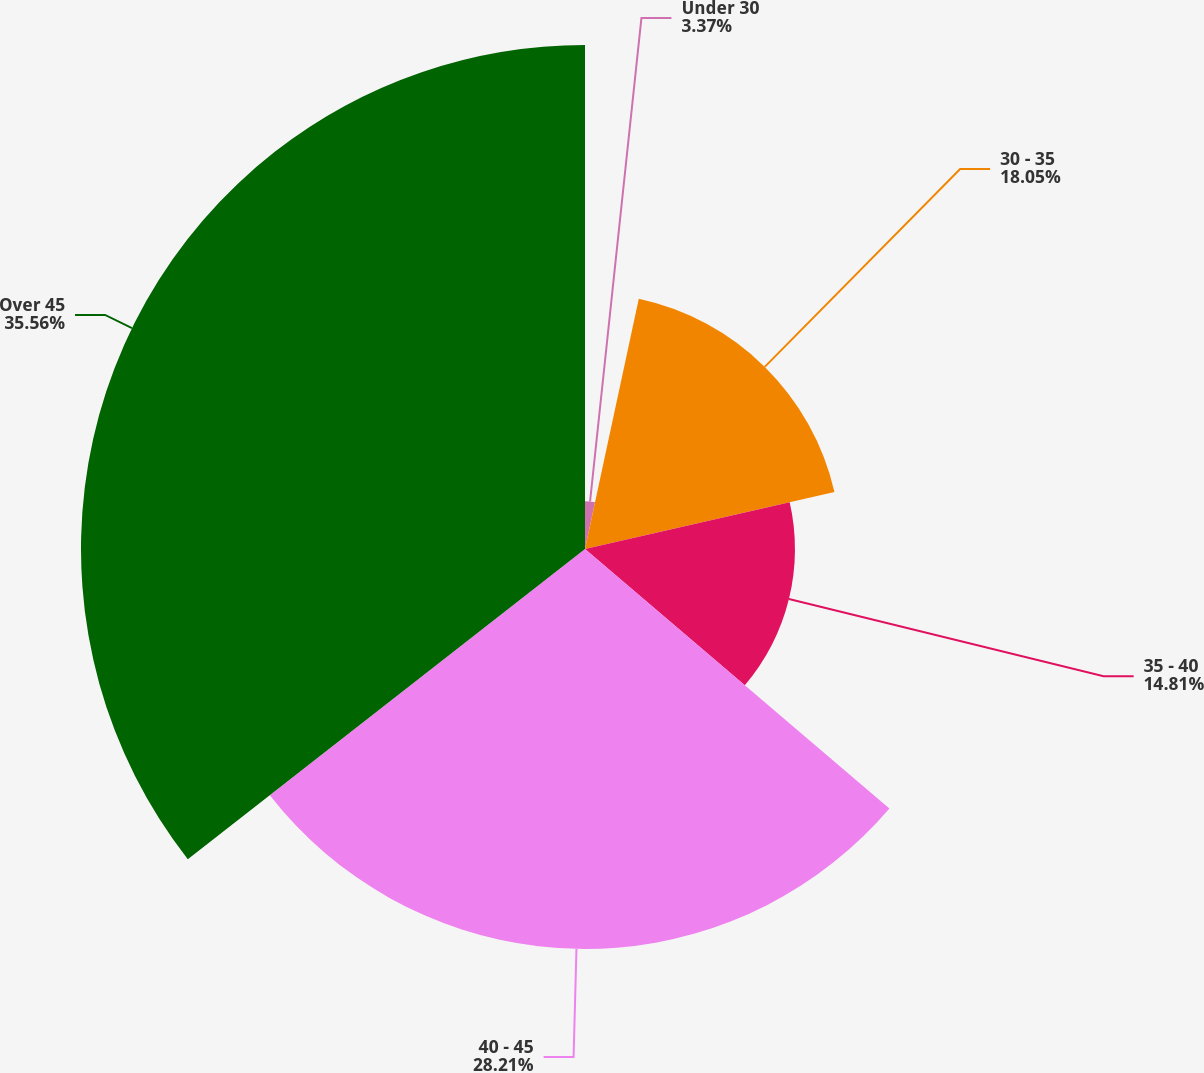<chart> <loc_0><loc_0><loc_500><loc_500><pie_chart><fcel>Under 30<fcel>30 - 35<fcel>35 - 40<fcel>40 - 45<fcel>Over 45<nl><fcel>3.37%<fcel>18.05%<fcel>14.81%<fcel>28.21%<fcel>35.55%<nl></chart> 